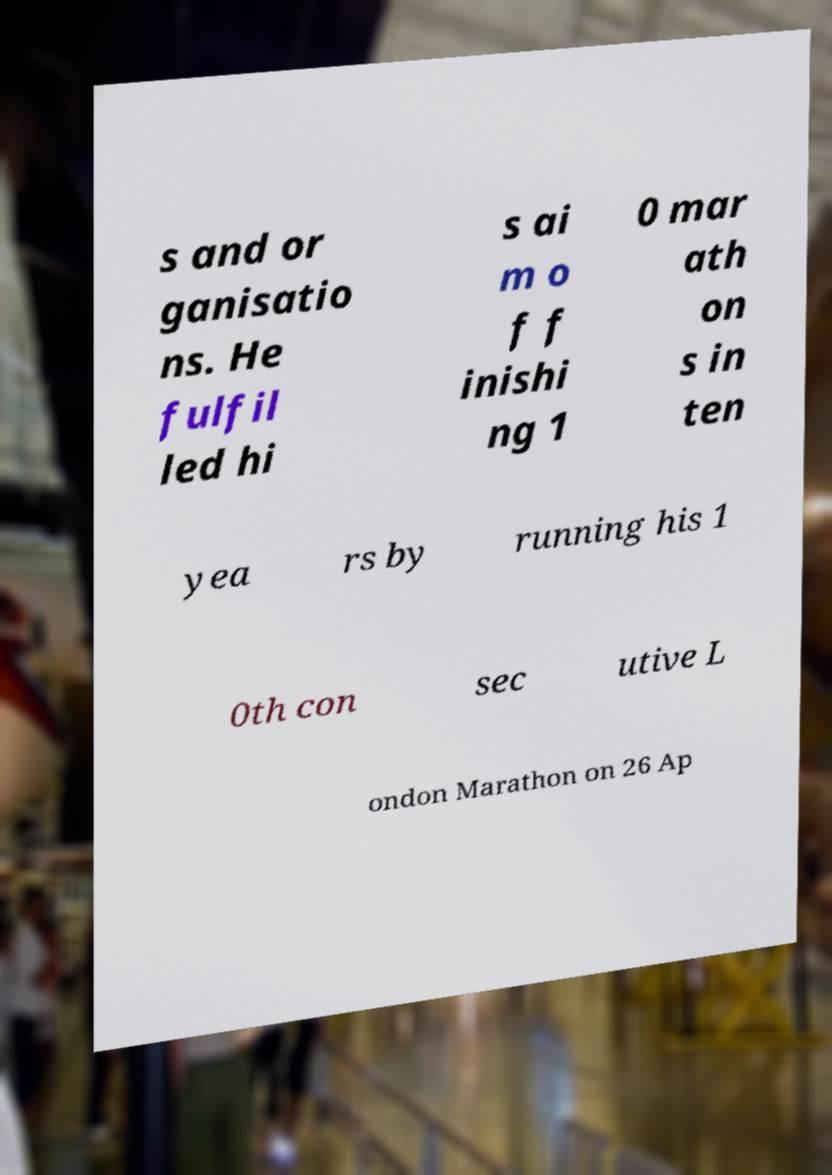Please identify and transcribe the text found in this image. s and or ganisatio ns. He fulfil led hi s ai m o f f inishi ng 1 0 mar ath on s in ten yea rs by running his 1 0th con sec utive L ondon Marathon on 26 Ap 